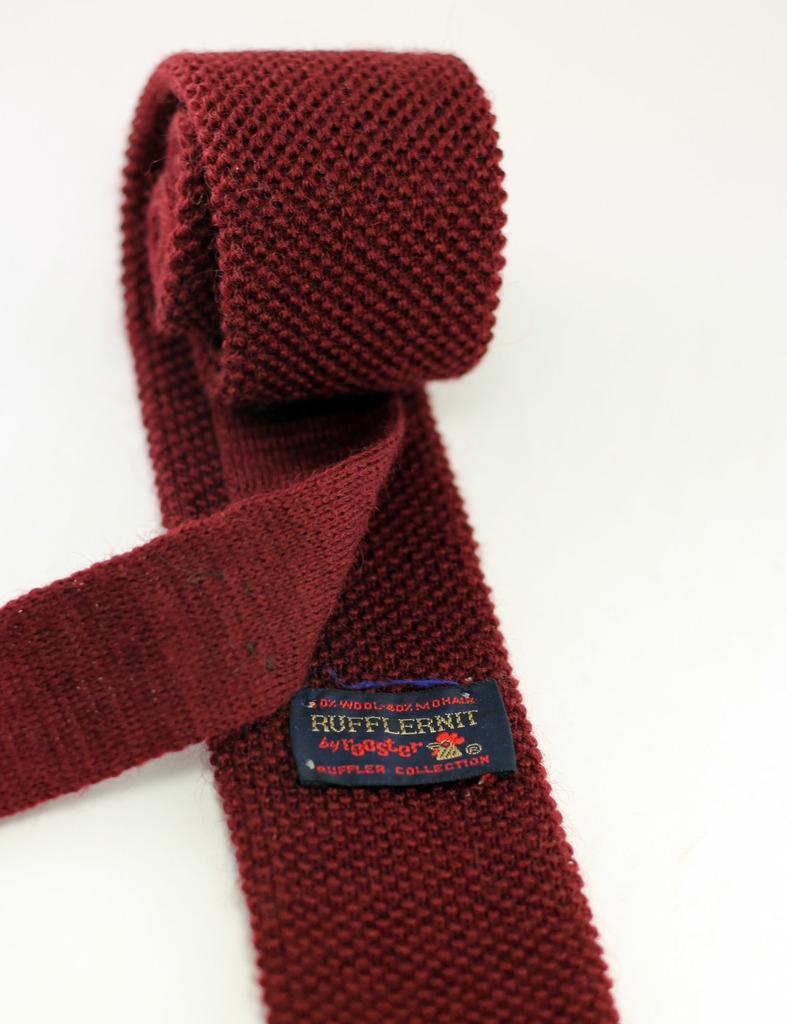Describe this image in one or two sentences. In this image we can see an object, which looks like a belt and the background is white. 